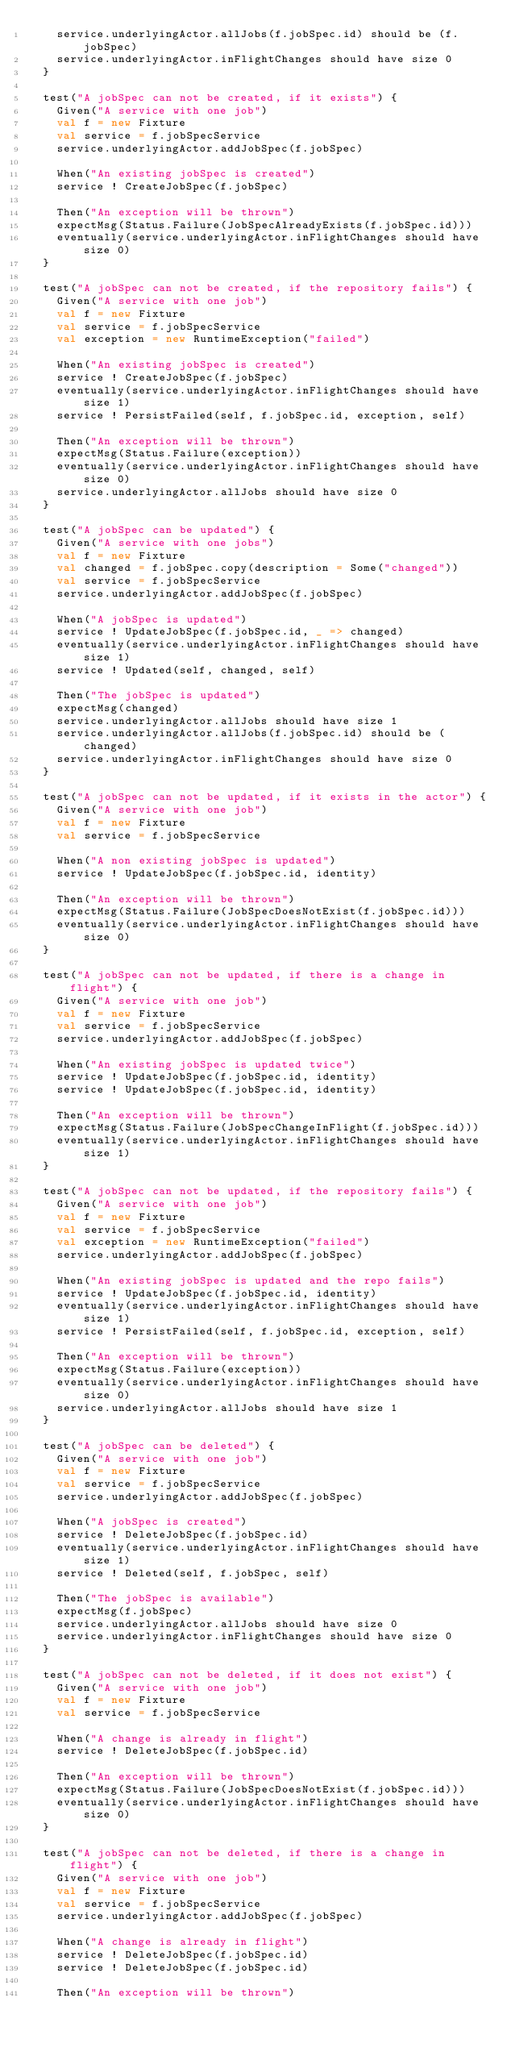Convert code to text. <code><loc_0><loc_0><loc_500><loc_500><_Scala_>    service.underlyingActor.allJobs(f.jobSpec.id) should be (f.jobSpec)
    service.underlyingActor.inFlightChanges should have size 0
  }

  test("A jobSpec can not be created, if it exists") {
    Given("A service with one job")
    val f = new Fixture
    val service = f.jobSpecService
    service.underlyingActor.addJobSpec(f.jobSpec)

    When("An existing jobSpec is created")
    service ! CreateJobSpec(f.jobSpec)

    Then("An exception will be thrown")
    expectMsg(Status.Failure(JobSpecAlreadyExists(f.jobSpec.id)))
    eventually(service.underlyingActor.inFlightChanges should have size 0)
  }

  test("A jobSpec can not be created, if the repository fails") {
    Given("A service with one job")
    val f = new Fixture
    val service = f.jobSpecService
    val exception = new RuntimeException("failed")

    When("An existing jobSpec is created")
    service ! CreateJobSpec(f.jobSpec)
    eventually(service.underlyingActor.inFlightChanges should have size 1)
    service ! PersistFailed(self, f.jobSpec.id, exception, self)

    Then("An exception will be thrown")
    expectMsg(Status.Failure(exception))
    eventually(service.underlyingActor.inFlightChanges should have size 0)
    service.underlyingActor.allJobs should have size 0
  }

  test("A jobSpec can be updated") {
    Given("A service with one jobs")
    val f = new Fixture
    val changed = f.jobSpec.copy(description = Some("changed"))
    val service = f.jobSpecService
    service.underlyingActor.addJobSpec(f.jobSpec)

    When("A jobSpec is updated")
    service ! UpdateJobSpec(f.jobSpec.id, _ => changed)
    eventually(service.underlyingActor.inFlightChanges should have size 1)
    service ! Updated(self, changed, self)

    Then("The jobSpec is updated")
    expectMsg(changed)
    service.underlyingActor.allJobs should have size 1
    service.underlyingActor.allJobs(f.jobSpec.id) should be (changed)
    service.underlyingActor.inFlightChanges should have size 0
  }

  test("A jobSpec can not be updated, if it exists in the actor") {
    Given("A service with one job")
    val f = new Fixture
    val service = f.jobSpecService

    When("A non existing jobSpec is updated")
    service ! UpdateJobSpec(f.jobSpec.id, identity)

    Then("An exception will be thrown")
    expectMsg(Status.Failure(JobSpecDoesNotExist(f.jobSpec.id)))
    eventually(service.underlyingActor.inFlightChanges should have size 0)
  }

  test("A jobSpec can not be updated, if there is a change in flight") {
    Given("A service with one job")
    val f = new Fixture
    val service = f.jobSpecService
    service.underlyingActor.addJobSpec(f.jobSpec)

    When("An existing jobSpec is updated twice")
    service ! UpdateJobSpec(f.jobSpec.id, identity)
    service ! UpdateJobSpec(f.jobSpec.id, identity)

    Then("An exception will be thrown")
    expectMsg(Status.Failure(JobSpecChangeInFlight(f.jobSpec.id)))
    eventually(service.underlyingActor.inFlightChanges should have size 1)
  }

  test("A jobSpec can not be updated, if the repository fails") {
    Given("A service with one job")
    val f = new Fixture
    val service = f.jobSpecService
    val exception = new RuntimeException("failed")
    service.underlyingActor.addJobSpec(f.jobSpec)

    When("An existing jobSpec is updated and the repo fails")
    service ! UpdateJobSpec(f.jobSpec.id, identity)
    eventually(service.underlyingActor.inFlightChanges should have size 1)
    service ! PersistFailed(self, f.jobSpec.id, exception, self)

    Then("An exception will be thrown")
    expectMsg(Status.Failure(exception))
    eventually(service.underlyingActor.inFlightChanges should have size 0)
    service.underlyingActor.allJobs should have size 1
  }

  test("A jobSpec can be deleted") {
    Given("A service with one job")
    val f = new Fixture
    val service = f.jobSpecService
    service.underlyingActor.addJobSpec(f.jobSpec)

    When("A jobSpec is created")
    service ! DeleteJobSpec(f.jobSpec.id)
    eventually(service.underlyingActor.inFlightChanges should have size 1)
    service ! Deleted(self, f.jobSpec, self)

    Then("The jobSpec is available")
    expectMsg(f.jobSpec)
    service.underlyingActor.allJobs should have size 0
    service.underlyingActor.inFlightChanges should have size 0
  }

  test("A jobSpec can not be deleted, if it does not exist") {
    Given("A service with one job")
    val f = new Fixture
    val service = f.jobSpecService

    When("A change is already in flight")
    service ! DeleteJobSpec(f.jobSpec.id)

    Then("An exception will be thrown")
    expectMsg(Status.Failure(JobSpecDoesNotExist(f.jobSpec.id)))
    eventually(service.underlyingActor.inFlightChanges should have size 0)
  }

  test("A jobSpec can not be deleted, if there is a change in flight") {
    Given("A service with one job")
    val f = new Fixture
    val service = f.jobSpecService
    service.underlyingActor.addJobSpec(f.jobSpec)

    When("A change is already in flight")
    service ! DeleteJobSpec(f.jobSpec.id)
    service ! DeleteJobSpec(f.jobSpec.id)

    Then("An exception will be thrown")</code> 